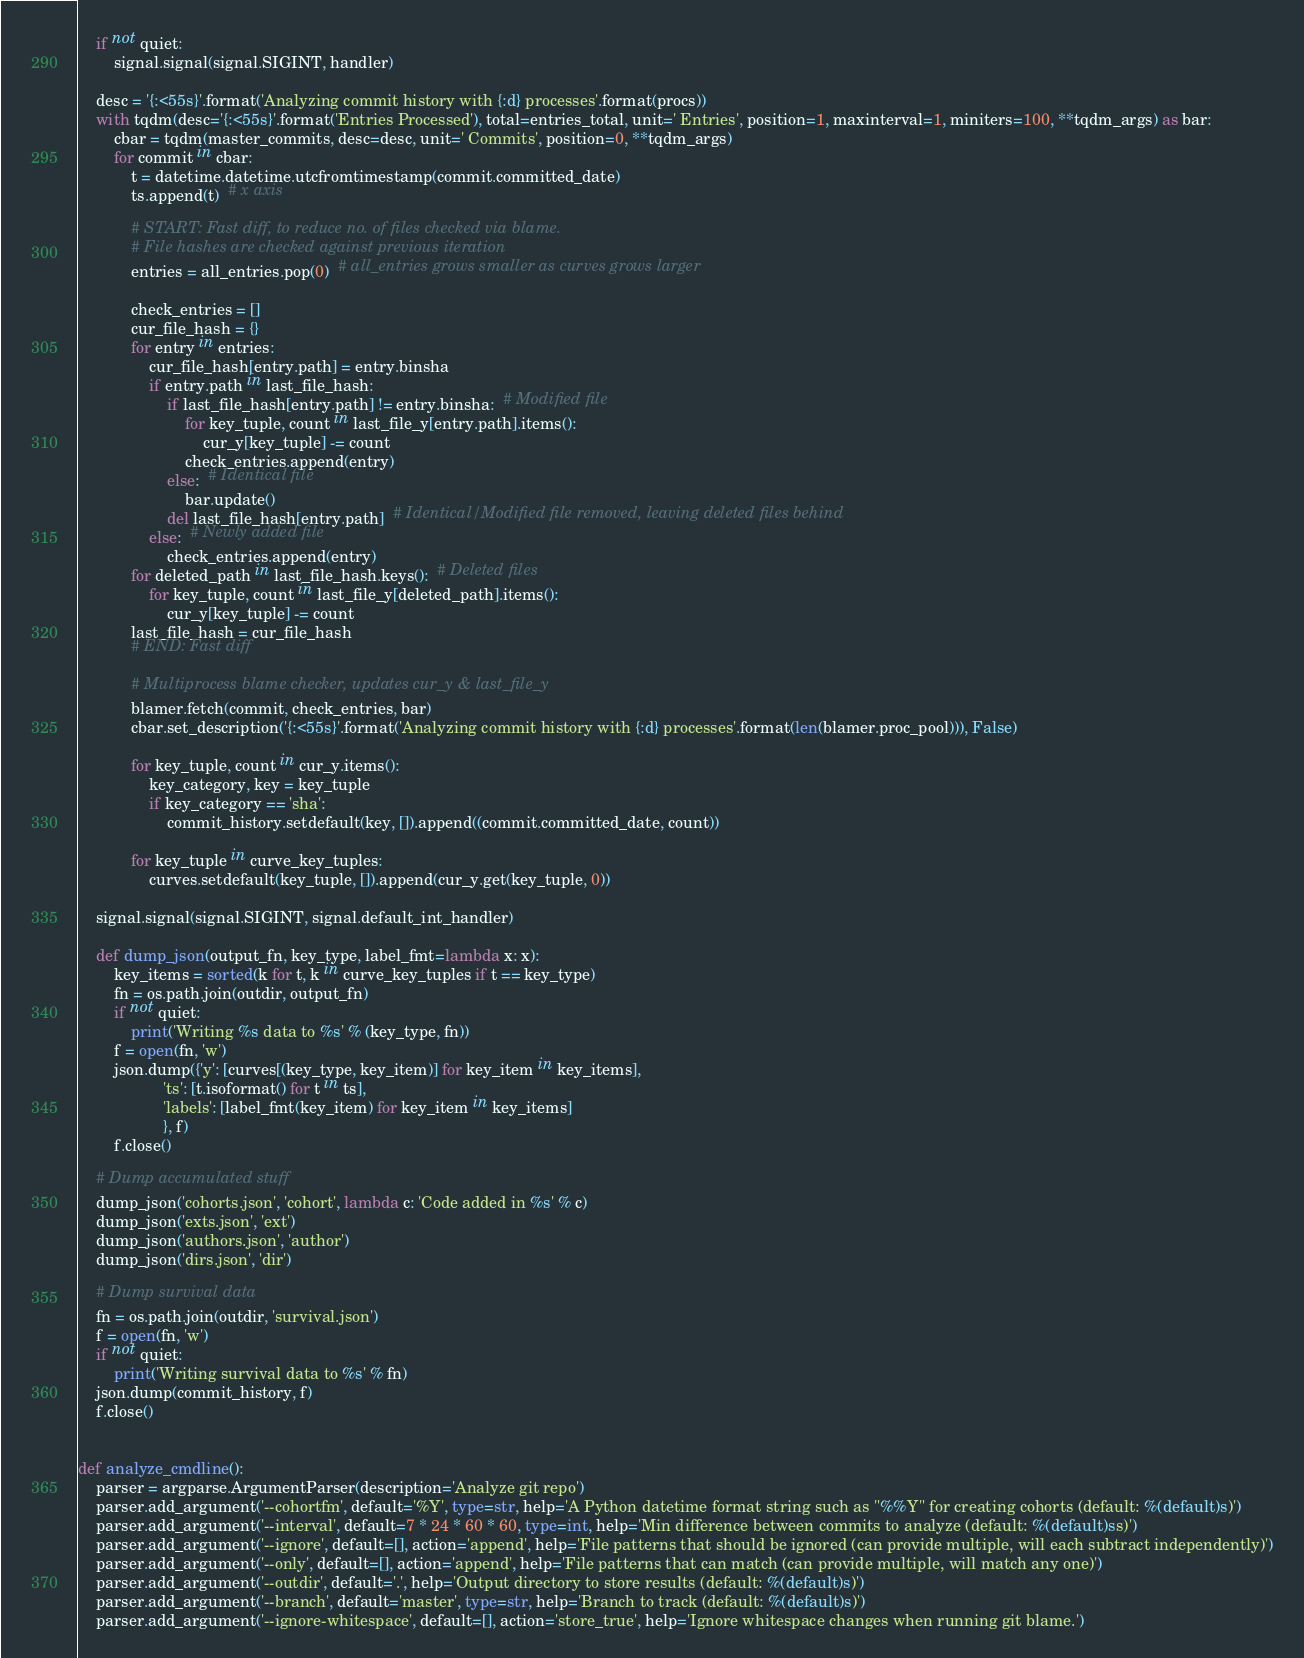<code> <loc_0><loc_0><loc_500><loc_500><_Python_>    if not quiet:
        signal.signal(signal.SIGINT, handler)

    desc = '{:<55s}'.format('Analyzing commit history with {:d} processes'.format(procs))
    with tqdm(desc='{:<55s}'.format('Entries Processed'), total=entries_total, unit=' Entries', position=1, maxinterval=1, miniters=100, **tqdm_args) as bar:
        cbar = tqdm(master_commits, desc=desc, unit=' Commits', position=0, **tqdm_args)
        for commit in cbar:
            t = datetime.datetime.utcfromtimestamp(commit.committed_date)
            ts.append(t)  # x axis

            # START: Fast diff, to reduce no. of files checked via blame.
            # File hashes are checked against previous iteration
            entries = all_entries.pop(0)  # all_entries grows smaller as curves grows larger

            check_entries = []
            cur_file_hash = {}
            for entry in entries:
                cur_file_hash[entry.path] = entry.binsha
                if entry.path in last_file_hash:
                    if last_file_hash[entry.path] != entry.binsha:  # Modified file
                        for key_tuple, count in last_file_y[entry.path].items():
                            cur_y[key_tuple] -= count
                        check_entries.append(entry)
                    else:  # Identical file
                        bar.update()
                    del last_file_hash[entry.path]  # Identical/Modified file removed, leaving deleted files behind
                else:  # Newly added file
                    check_entries.append(entry)
            for deleted_path in last_file_hash.keys():  # Deleted files
                for key_tuple, count in last_file_y[deleted_path].items():
                    cur_y[key_tuple] -= count
            last_file_hash = cur_file_hash
            # END: Fast diff

            # Multiprocess blame checker, updates cur_y & last_file_y
            blamer.fetch(commit, check_entries, bar)
            cbar.set_description('{:<55s}'.format('Analyzing commit history with {:d} processes'.format(len(blamer.proc_pool))), False)

            for key_tuple, count in cur_y.items():
                key_category, key = key_tuple
                if key_category == 'sha':
                    commit_history.setdefault(key, []).append((commit.committed_date, count))

            for key_tuple in curve_key_tuples:
                curves.setdefault(key_tuple, []).append(cur_y.get(key_tuple, 0))

    signal.signal(signal.SIGINT, signal.default_int_handler)

    def dump_json(output_fn, key_type, label_fmt=lambda x: x):
        key_items = sorted(k for t, k in curve_key_tuples if t == key_type)
        fn = os.path.join(outdir, output_fn)
        if not quiet:
            print('Writing %s data to %s' % (key_type, fn))
        f = open(fn, 'w')
        json.dump({'y': [curves[(key_type, key_item)] for key_item in key_items],
                   'ts': [t.isoformat() for t in ts],
                   'labels': [label_fmt(key_item) for key_item in key_items]
                   }, f)
        f.close()

    # Dump accumulated stuff
    dump_json('cohorts.json', 'cohort', lambda c: 'Code added in %s' % c)
    dump_json('exts.json', 'ext')
    dump_json('authors.json', 'author')
    dump_json('dirs.json', 'dir')

    # Dump survival data
    fn = os.path.join(outdir, 'survival.json')
    f = open(fn, 'w')
    if not quiet:
        print('Writing survival data to %s' % fn)
    json.dump(commit_history, f)
    f.close()


def analyze_cmdline():
    parser = argparse.ArgumentParser(description='Analyze git repo')
    parser.add_argument('--cohortfm', default='%Y', type=str, help='A Python datetime format string such as "%%Y" for creating cohorts (default: %(default)s)')
    parser.add_argument('--interval', default=7 * 24 * 60 * 60, type=int, help='Min difference between commits to analyze (default: %(default)ss)')
    parser.add_argument('--ignore', default=[], action='append', help='File patterns that should be ignored (can provide multiple, will each subtract independently)')
    parser.add_argument('--only', default=[], action='append', help='File patterns that can match (can provide multiple, will match any one)')
    parser.add_argument('--outdir', default='.', help='Output directory to store results (default: %(default)s)')
    parser.add_argument('--branch', default='master', type=str, help='Branch to track (default: %(default)s)')
    parser.add_argument('--ignore-whitespace', default=[], action='store_true', help='Ignore whitespace changes when running git blame.')</code> 